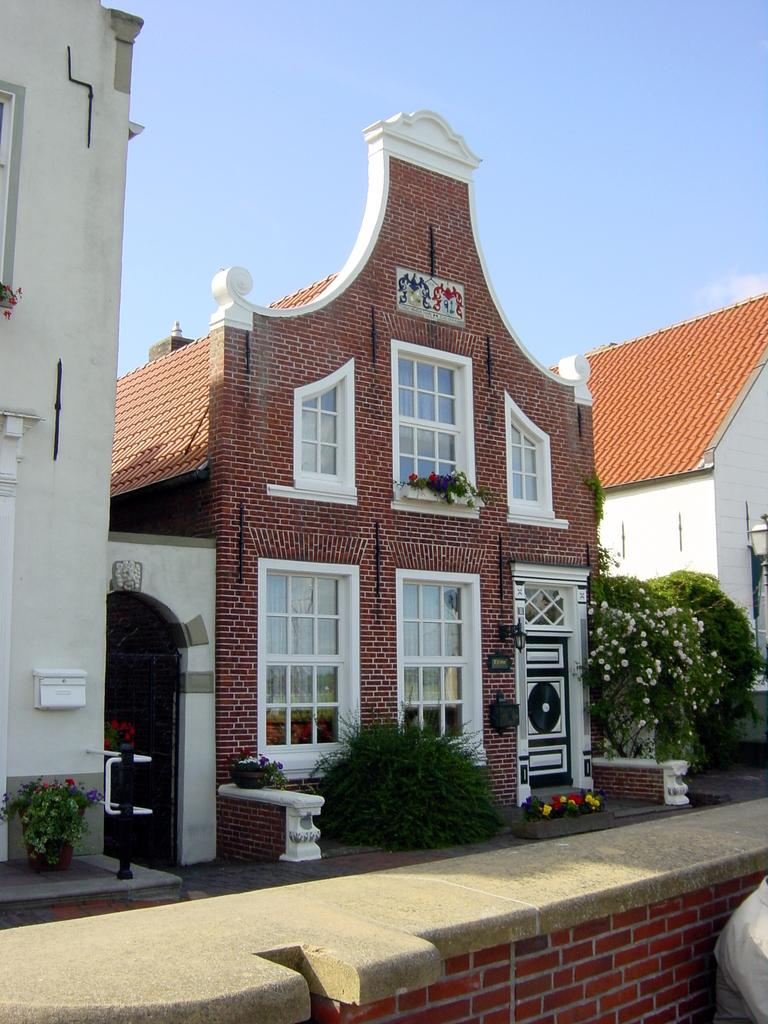What is located in the center of the image? There are buildings in the center of the image. What is visible at the top of the image? The sky is visible at the top of the image. What is at the bottom of the image? There is a wall at the bottom of the image. What type of vegetation can be seen in the image? There are plants in the image. What color is the copper statue in the image? There is no copper statue present in the image. How does the fog affect the visibility of the buildings in the image? There is no fog present in the image; the buildings are clearly visible. 